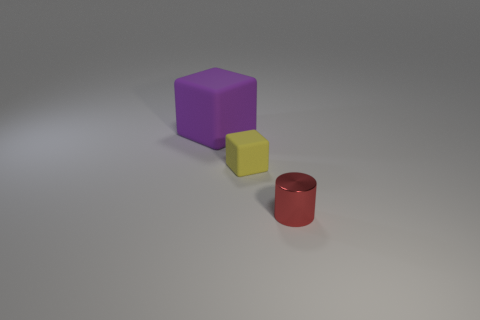Does the large rubber object have the same color as the rubber thing in front of the purple rubber object?
Ensure brevity in your answer.  No. What color is the matte block that is the same size as the red thing?
Ensure brevity in your answer.  Yellow. Is there a big brown shiny thing of the same shape as the large rubber thing?
Your response must be concise. No. Are there fewer yellow things than large blue metal balls?
Your answer should be very brief. No. What color is the block to the right of the purple object?
Keep it short and to the point. Yellow. There is a tiny thing that is behind the object that is right of the yellow cube; what is its shape?
Your answer should be very brief. Cube. Are the yellow block and the thing behind the tiny yellow rubber cube made of the same material?
Ensure brevity in your answer.  Yes. What number of yellow matte things are the same size as the purple cube?
Give a very brief answer. 0. Is the number of purple rubber cubes in front of the big purple matte cube less than the number of small red metallic things?
Offer a terse response. Yes. How many rubber objects are to the left of the yellow rubber object?
Provide a short and direct response. 1. 